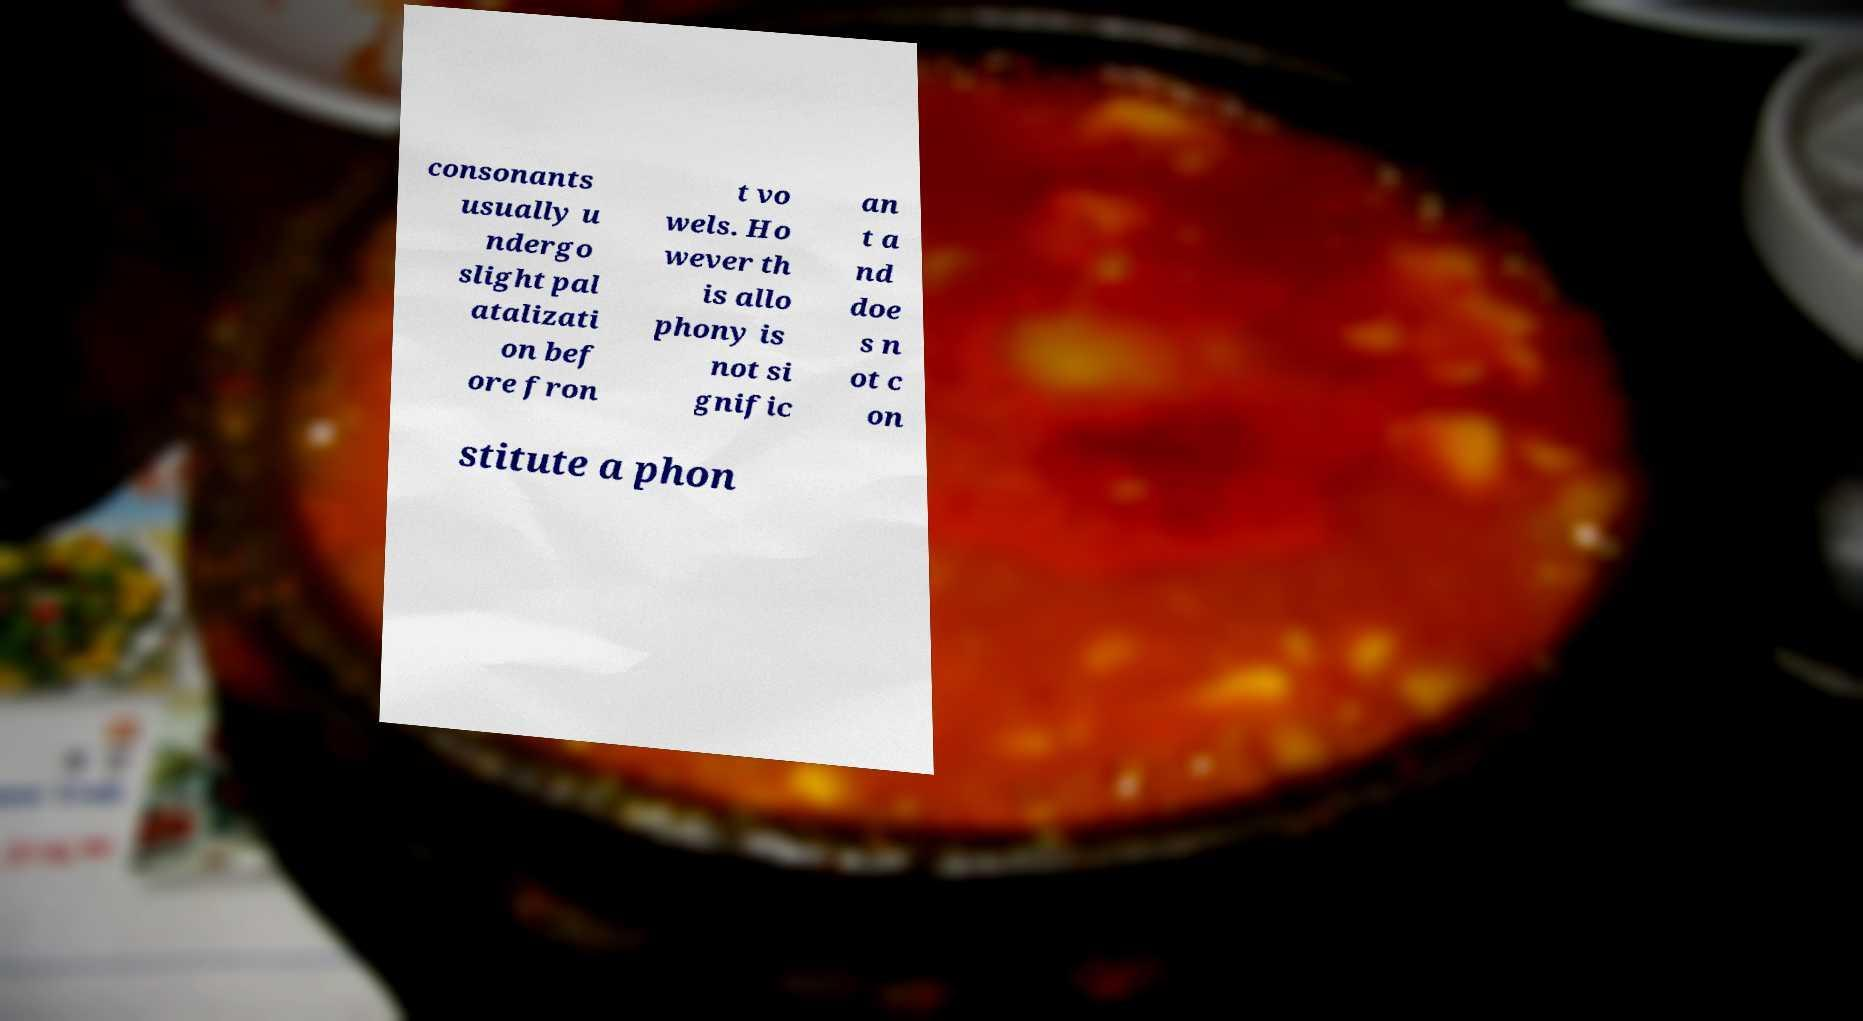Could you assist in decoding the text presented in this image and type it out clearly? consonants usually u ndergo slight pal atalizati on bef ore fron t vo wels. Ho wever th is allo phony is not si gnific an t a nd doe s n ot c on stitute a phon 